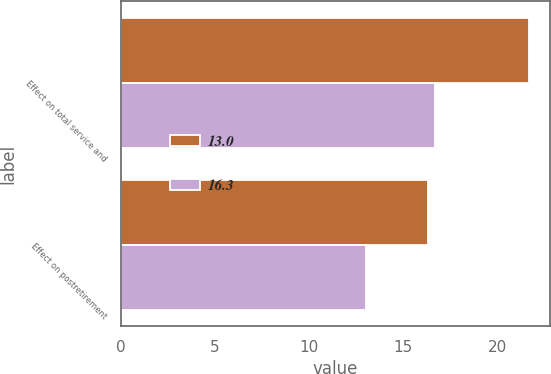Convert chart to OTSL. <chart><loc_0><loc_0><loc_500><loc_500><stacked_bar_chart><ecel><fcel>Effect on total service and<fcel>Effect on postretirement<nl><fcel>13<fcel>21.7<fcel>16.3<nl><fcel>16.3<fcel>16.7<fcel>13<nl></chart> 